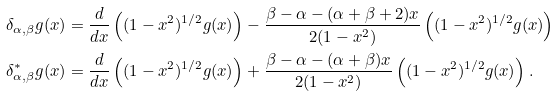Convert formula to latex. <formula><loc_0><loc_0><loc_500><loc_500>\delta _ { \alpha , \beta } g ( x ) & = \frac { d } { d x } \left ( ( 1 - x ^ { 2 } ) ^ { 1 / 2 } g ( x ) \right ) - \frac { \beta - \alpha - ( \alpha + \beta + 2 ) x } { 2 ( 1 - x ^ { 2 } ) } \left ( ( 1 - x ^ { 2 } ) ^ { 1 / 2 } g ( x ) \right ) \\ \delta _ { \alpha , \beta } ^ { * } g ( x ) & = \frac { d } { d x } \left ( ( 1 - x ^ { 2 } ) ^ { 1 / 2 } g ( x ) \right ) + \frac { \beta - \alpha - ( \alpha + \beta ) x } { 2 ( 1 - x ^ { 2 } ) } \left ( ( 1 - x ^ { 2 } ) ^ { 1 / 2 } g ( x ) \right ) .</formula> 